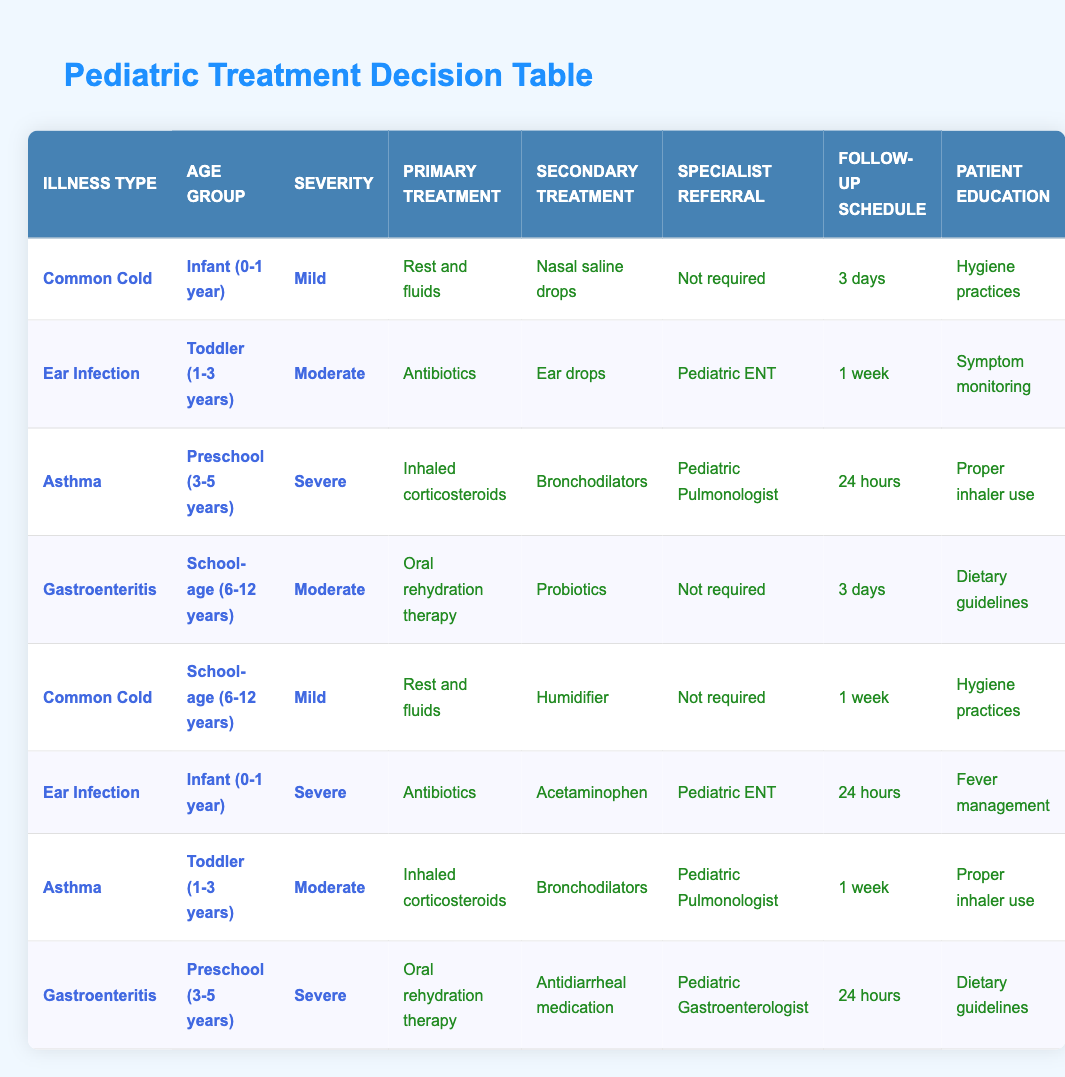What is the primary treatment for a Common Cold in an Infant with Mild severity? The table indicates that for a Common Cold in an Infant (0-1 year) with Mild severity, the primary treatment is "Rest and fluids."
Answer: Rest and fluids How long is the follow-up schedule for a Gastroenteritis case in a School-age child with Moderate severity? According to the table, the follow-up schedule for Gastroenteritis in a School-age child (6-12 years) with Moderate severity is "3 days."
Answer: 3 days Is a Pediatric ENT referral required for an Ear Infection in a Toddler with Moderate severity? The table shows that a referral to a Pediatric ENT is required for an Ear Infection in a Toddler (1-3 years) with Moderate severity. Therefore, the answer is yes.
Answer: Yes What are the secondary treatments prescribed for Severe Asthma in a Preschool child? For Severe Asthma in a Preschool child (3-5 years), the secondary treatments listed are "Bronchodilators." Thus, the answer identifies the specific treatment prescribed.
Answer: Bronchodilators What is the average follow-up schedule for Common Cold cases across all age groups and severity levels? The follow-up schedules for Common Cold cases are 3 days (Infant, Mild) and 1 week (School-age, Mild). To find the average, we sum these values (3 + 7 = 10, since 1 week = 7 days) and divide by the number of cases (2). The average is 10/2 = 5 days.
Answer: 5 days Does a Pediatric Gastroenterologist referral apply to a School-age child with Moderate Gastroenteritis? The table indicates that for Gastroenteritis in a School-age child, a referral is marked as "Not required." Thus, the answer is no.
Answer: No What is the primary treatment for Severe Ear Infection in an Infant? The table shows that the primary treatment for Severe Ear Infection in an Infant (0-1 year) is "Antibiotics." This answer directly reflects the data provided in the table.
Answer: Antibiotics What patient education is recommended for a Preschool child with Severe Gastroenteritis? The table states that for Severe Gastroenteritis in a Preschool child (3-5 years), the recommended patient education is "Dietary guidelines." This highlights the specific education tailored to this condition.
Answer: Dietary guidelines How many different conditions require a Pediatric Pulmonologist referral, and what are they? The table indicates that a Pediatric Pulmonologist referral is required for Severe Asthma (Preschool, 3-5 years) and Moderate Asthma (Toddler, 1-3 years). Therefore, there are two conditions requiring such a referral: Severe Asthma and Moderate Asthma.
Answer: 2 conditions (Severe Asthma, Moderate Asthma) 